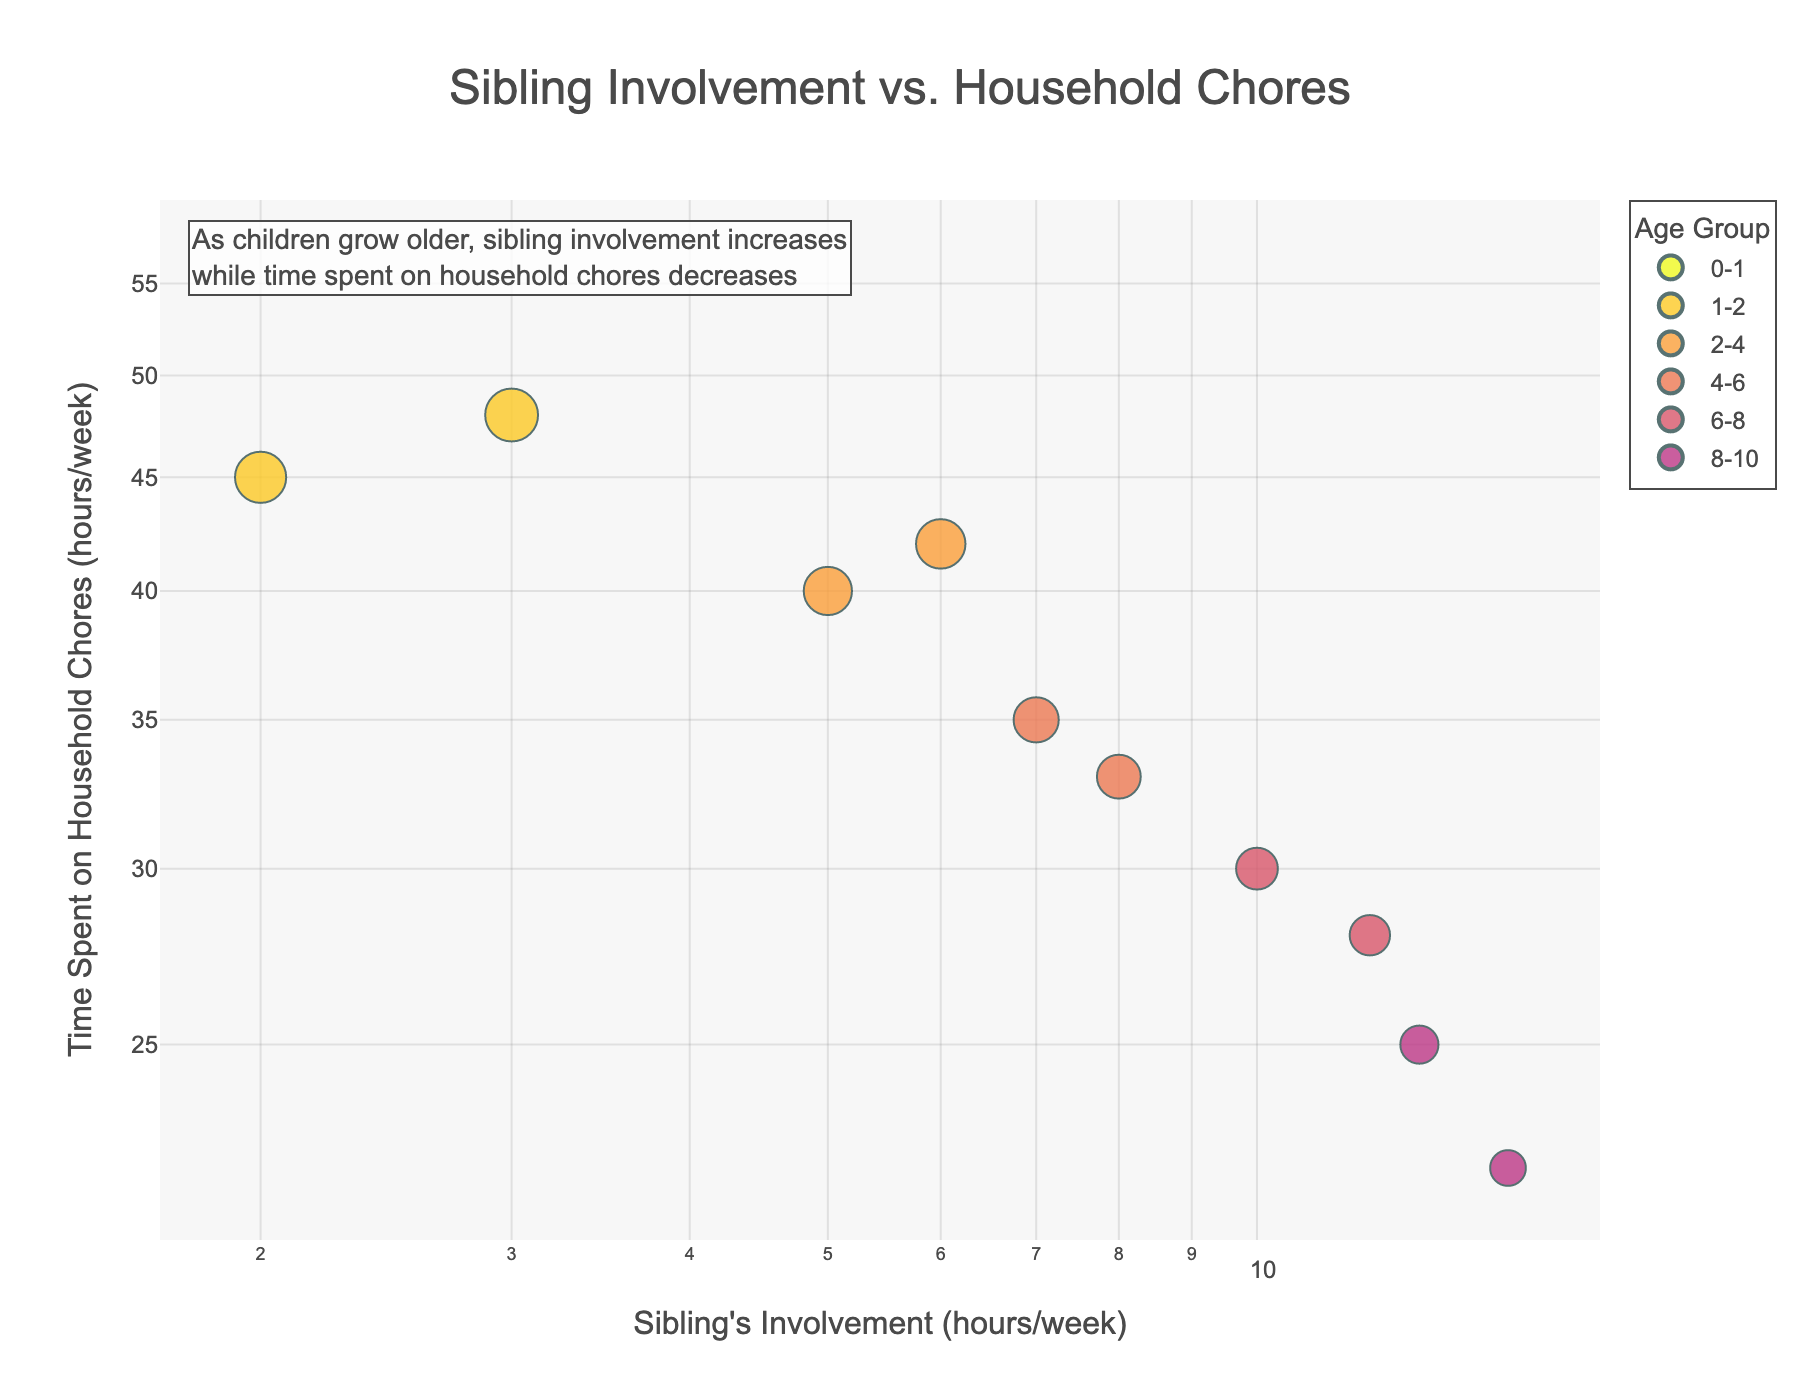What is the title of the plot? The title is clearly visible at the top of the plot and reads, "Sibling Involvement vs. Household Chores".
Answer: Sibling Involvement vs. Household Chores What are the axis titles on this plot? The x-axis is titled "Sibling's Involvement (hours/week)", and the y-axis is titled "Time Spent on Household Chores (hours/week)".
Answer: Sibling's Involvement (hours/week), Time Spent on Household Chores (hours/week) Which age group has the highest sibling involvement? By looking at the color-coded data points alongside the legend, the age group 8-10 years has the highest sibling involvement, with points around 13 and 15 hours/week.
Answer: 8-10 years How does the time spent on household chores change as sibling involvement increases? By examining the trend of data points in the scatter plot, it is apparent that as sibling involvement increases, the time spent on household chores generally decreases.
Answer: Decreases How many data points are there for the age group 4-6 years? By checking the legend and identifying the colors corresponding to the age group 4-6 years, we can count the number of points which is two.
Answer: 2 Is there any age group where the sibling's involvement is zero? By analyzing the plot, we notice data points for the age group 0-1 years where sibling involvement is zero hours/week.
Answer: 0-1 years What is the range of time spent on household chores for the age group 2-4 years? By observing the vertical spread of data points for the age group 2-4 years, the time spent ranges between 40 and 42 hours/week.
Answer: 40-42 hours/week Which age group sees the biggest drop in time spent on household chores as sibling involvement increases? By comparing the slopes of data points across age groups, the age group 6-8 years shows a significant decrease from 30 to 28 hours per week as sibling involvement increases from 10 to 12 hours per week.
Answer: 6-8 years 